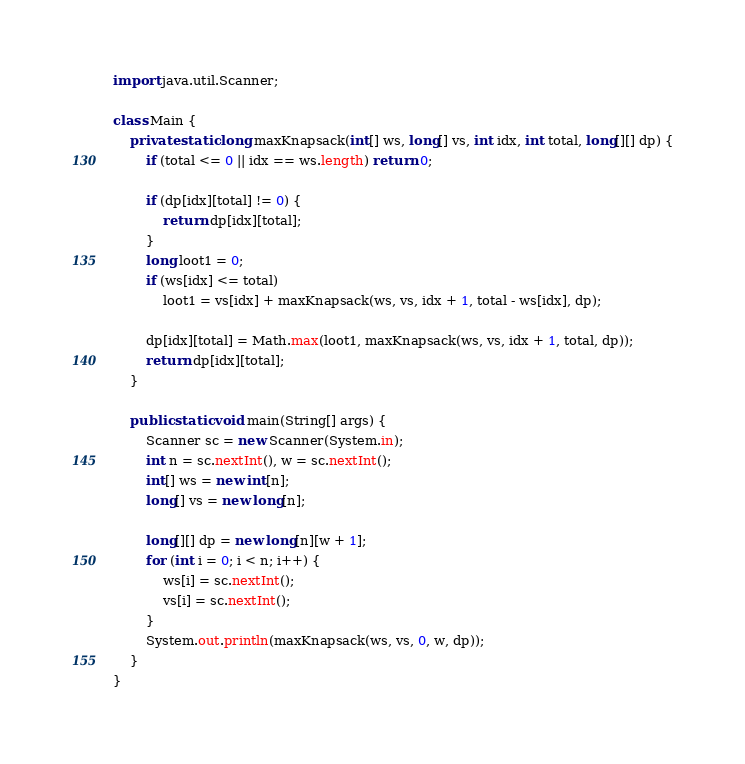<code> <loc_0><loc_0><loc_500><loc_500><_Java_>
import java.util.Scanner;

class Main {
    private static long maxKnapsack(int[] ws, long[] vs, int idx, int total, long[][] dp) {
        if (total <= 0 || idx == ws.length) return 0;

        if (dp[idx][total] != 0) {
            return dp[idx][total];
        }
        long loot1 = 0;
        if (ws[idx] <= total)
            loot1 = vs[idx] + maxKnapsack(ws, vs, idx + 1, total - ws[idx], dp);

        dp[idx][total] = Math.max(loot1, maxKnapsack(ws, vs, idx + 1, total, dp));
        return dp[idx][total];
    }

    public static void main(String[] args) {
        Scanner sc = new Scanner(System.in);
        int n = sc.nextInt(), w = sc.nextInt();
        int[] ws = new int[n];
        long[] vs = new long[n];

        long[][] dp = new long[n][w + 1];
        for (int i = 0; i < n; i++) {
            ws[i] = sc.nextInt();
            vs[i] = sc.nextInt();
        }
        System.out.println(maxKnapsack(ws, vs, 0, w, dp));
    }
}

</code> 